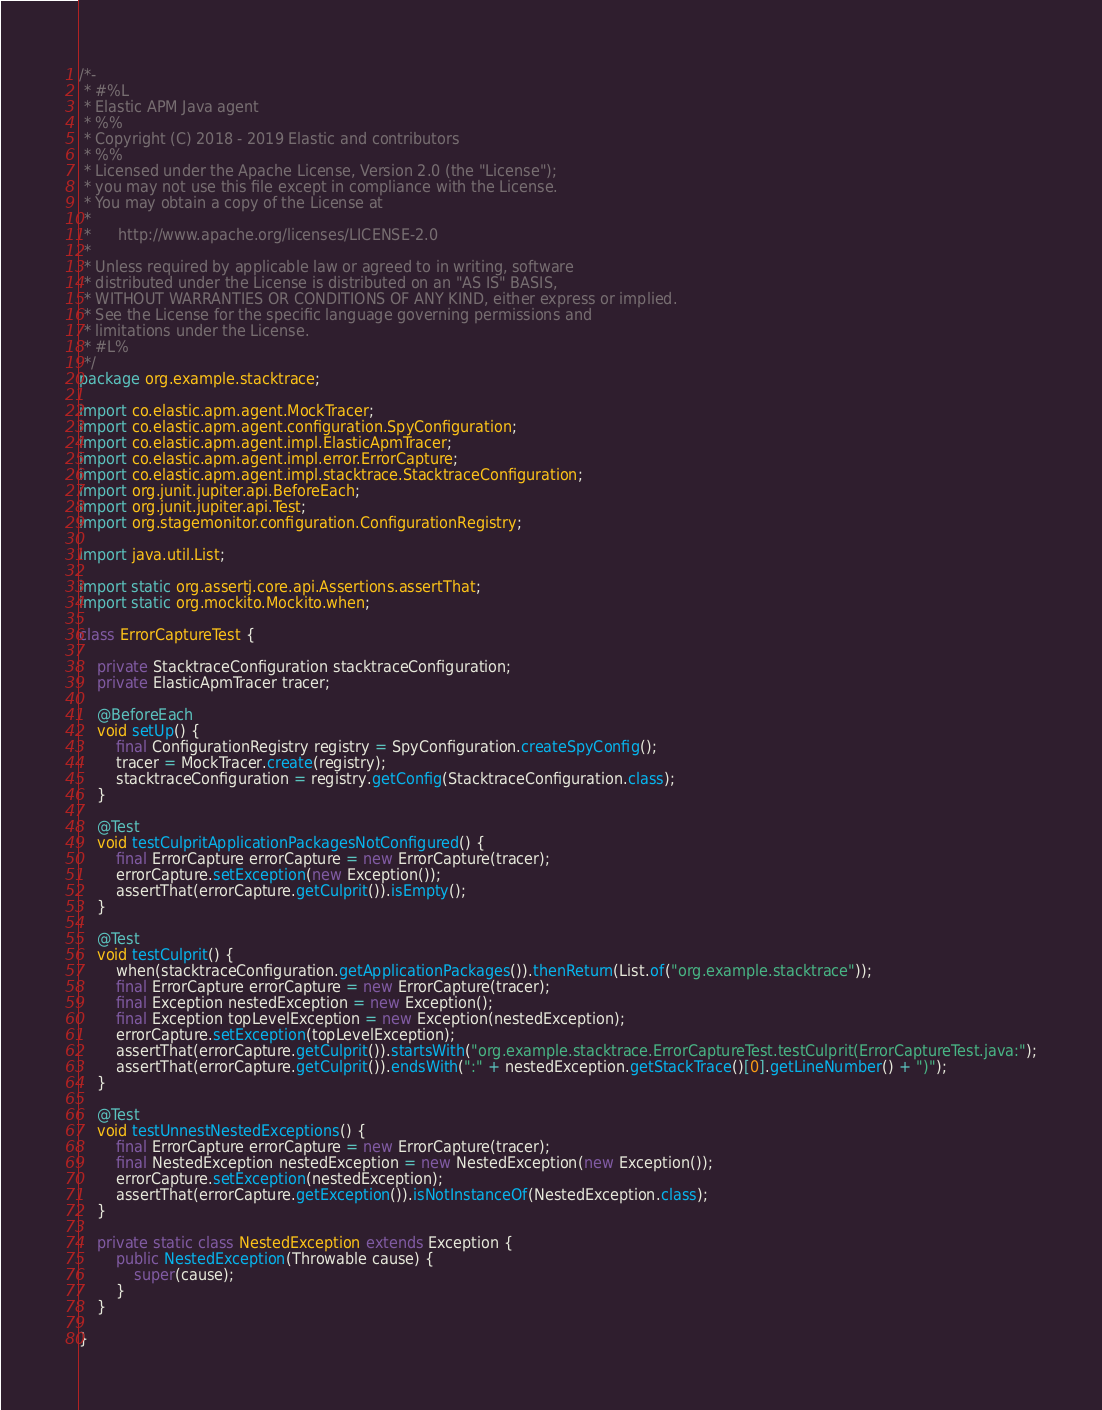<code> <loc_0><loc_0><loc_500><loc_500><_Java_>/*-
 * #%L
 * Elastic APM Java agent
 * %%
 * Copyright (C) 2018 - 2019 Elastic and contributors
 * %%
 * Licensed under the Apache License, Version 2.0 (the "License");
 * you may not use this file except in compliance with the License.
 * You may obtain a copy of the License at
 *
 *      http://www.apache.org/licenses/LICENSE-2.0
 *
 * Unless required by applicable law or agreed to in writing, software
 * distributed under the License is distributed on an "AS IS" BASIS,
 * WITHOUT WARRANTIES OR CONDITIONS OF ANY KIND, either express or implied.
 * See the License for the specific language governing permissions and
 * limitations under the License.
 * #L%
 */
package org.example.stacktrace;

import co.elastic.apm.agent.MockTracer;
import co.elastic.apm.agent.configuration.SpyConfiguration;
import co.elastic.apm.agent.impl.ElasticApmTracer;
import co.elastic.apm.agent.impl.error.ErrorCapture;
import co.elastic.apm.agent.impl.stacktrace.StacktraceConfiguration;
import org.junit.jupiter.api.BeforeEach;
import org.junit.jupiter.api.Test;
import org.stagemonitor.configuration.ConfigurationRegistry;

import java.util.List;

import static org.assertj.core.api.Assertions.assertThat;
import static org.mockito.Mockito.when;

class ErrorCaptureTest {

    private StacktraceConfiguration stacktraceConfiguration;
    private ElasticApmTracer tracer;

    @BeforeEach
    void setUp() {
        final ConfigurationRegistry registry = SpyConfiguration.createSpyConfig();
        tracer = MockTracer.create(registry);
        stacktraceConfiguration = registry.getConfig(StacktraceConfiguration.class);
    }

    @Test
    void testCulpritApplicationPackagesNotConfigured() {
        final ErrorCapture errorCapture = new ErrorCapture(tracer);
        errorCapture.setException(new Exception());
        assertThat(errorCapture.getCulprit()).isEmpty();
    }

    @Test
    void testCulprit() {
        when(stacktraceConfiguration.getApplicationPackages()).thenReturn(List.of("org.example.stacktrace"));
        final ErrorCapture errorCapture = new ErrorCapture(tracer);
        final Exception nestedException = new Exception();
        final Exception topLevelException = new Exception(nestedException);
        errorCapture.setException(topLevelException);
        assertThat(errorCapture.getCulprit()).startsWith("org.example.stacktrace.ErrorCaptureTest.testCulprit(ErrorCaptureTest.java:");
        assertThat(errorCapture.getCulprit()).endsWith(":" + nestedException.getStackTrace()[0].getLineNumber() + ")");
    }

    @Test
    void testUnnestNestedExceptions() {
        final ErrorCapture errorCapture = new ErrorCapture(tracer);
        final NestedException nestedException = new NestedException(new Exception());
        errorCapture.setException(nestedException);
        assertThat(errorCapture.getException()).isNotInstanceOf(NestedException.class);
    }

    private static class NestedException extends Exception {
        public NestedException(Throwable cause) {
            super(cause);
        }
    }

}
</code> 